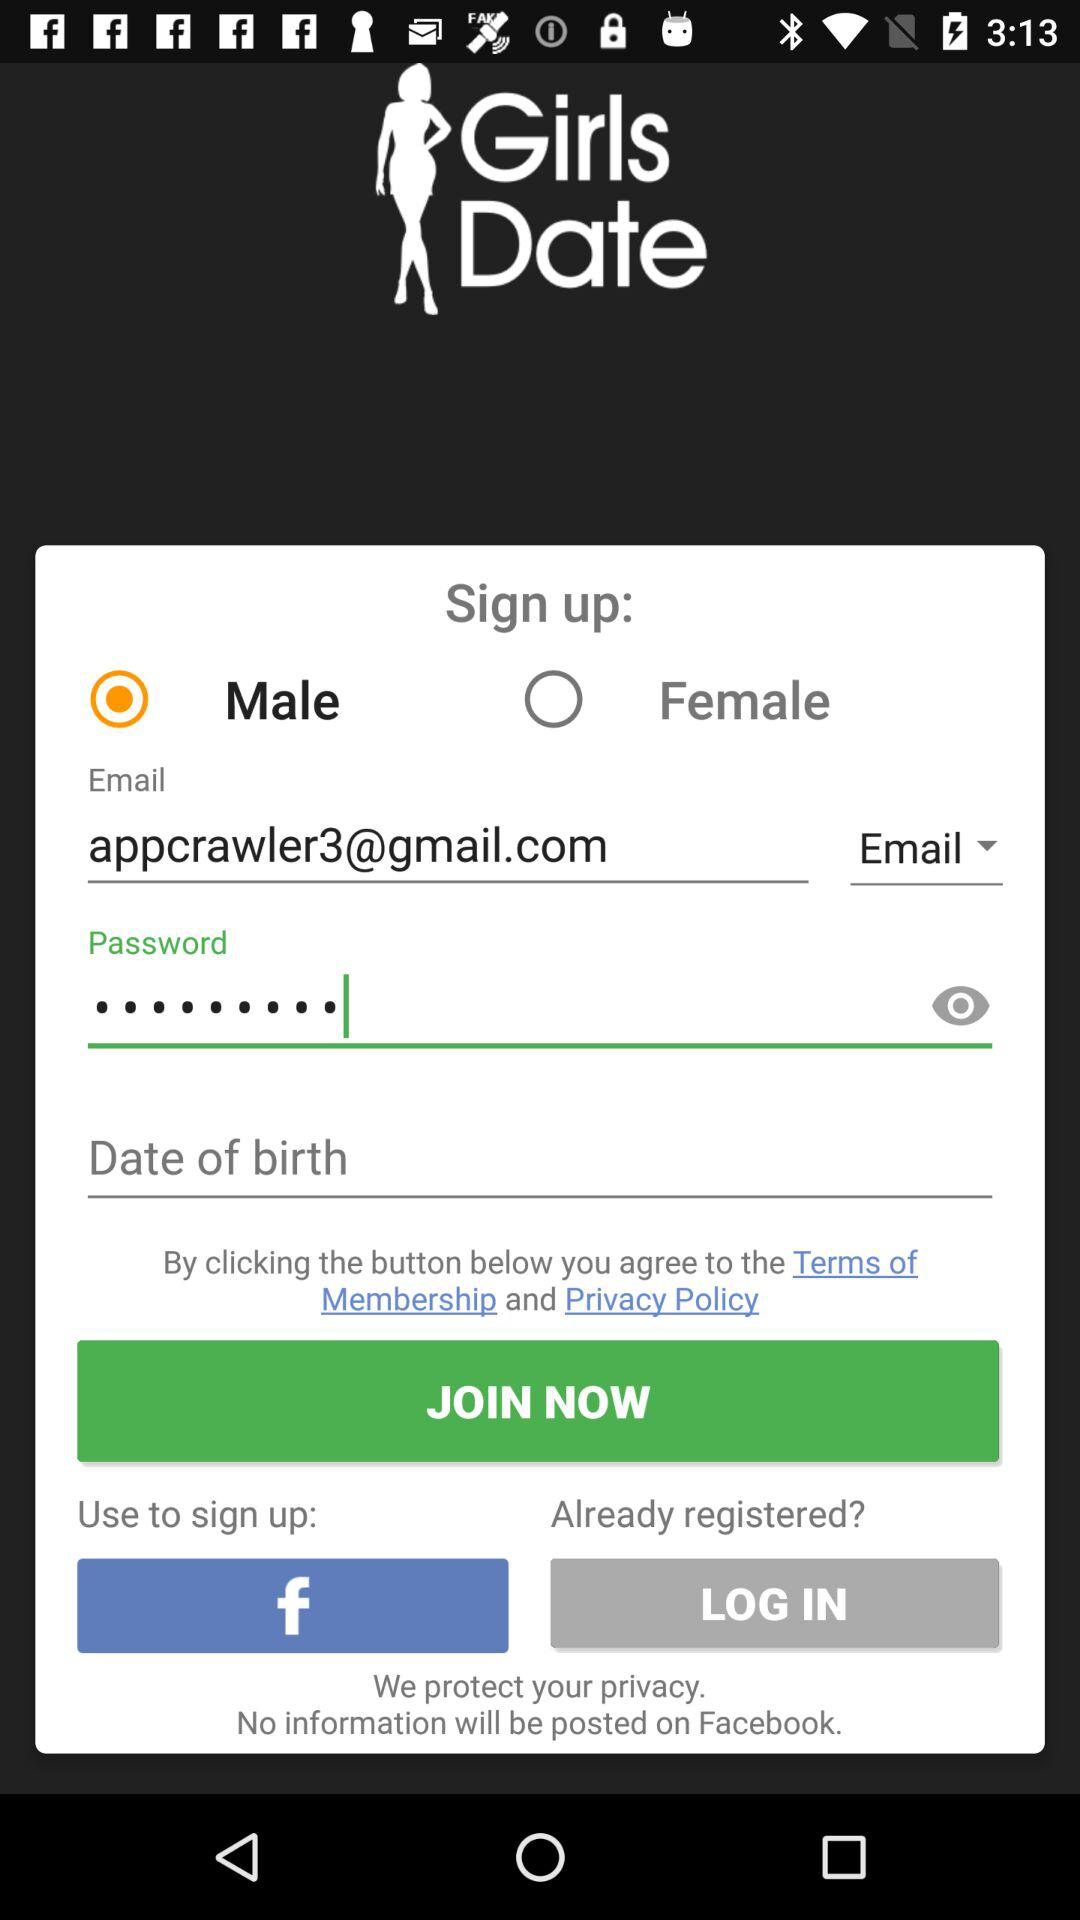What Gmail address is used? The used Gmail address is appcrawler3@gmail.com. 